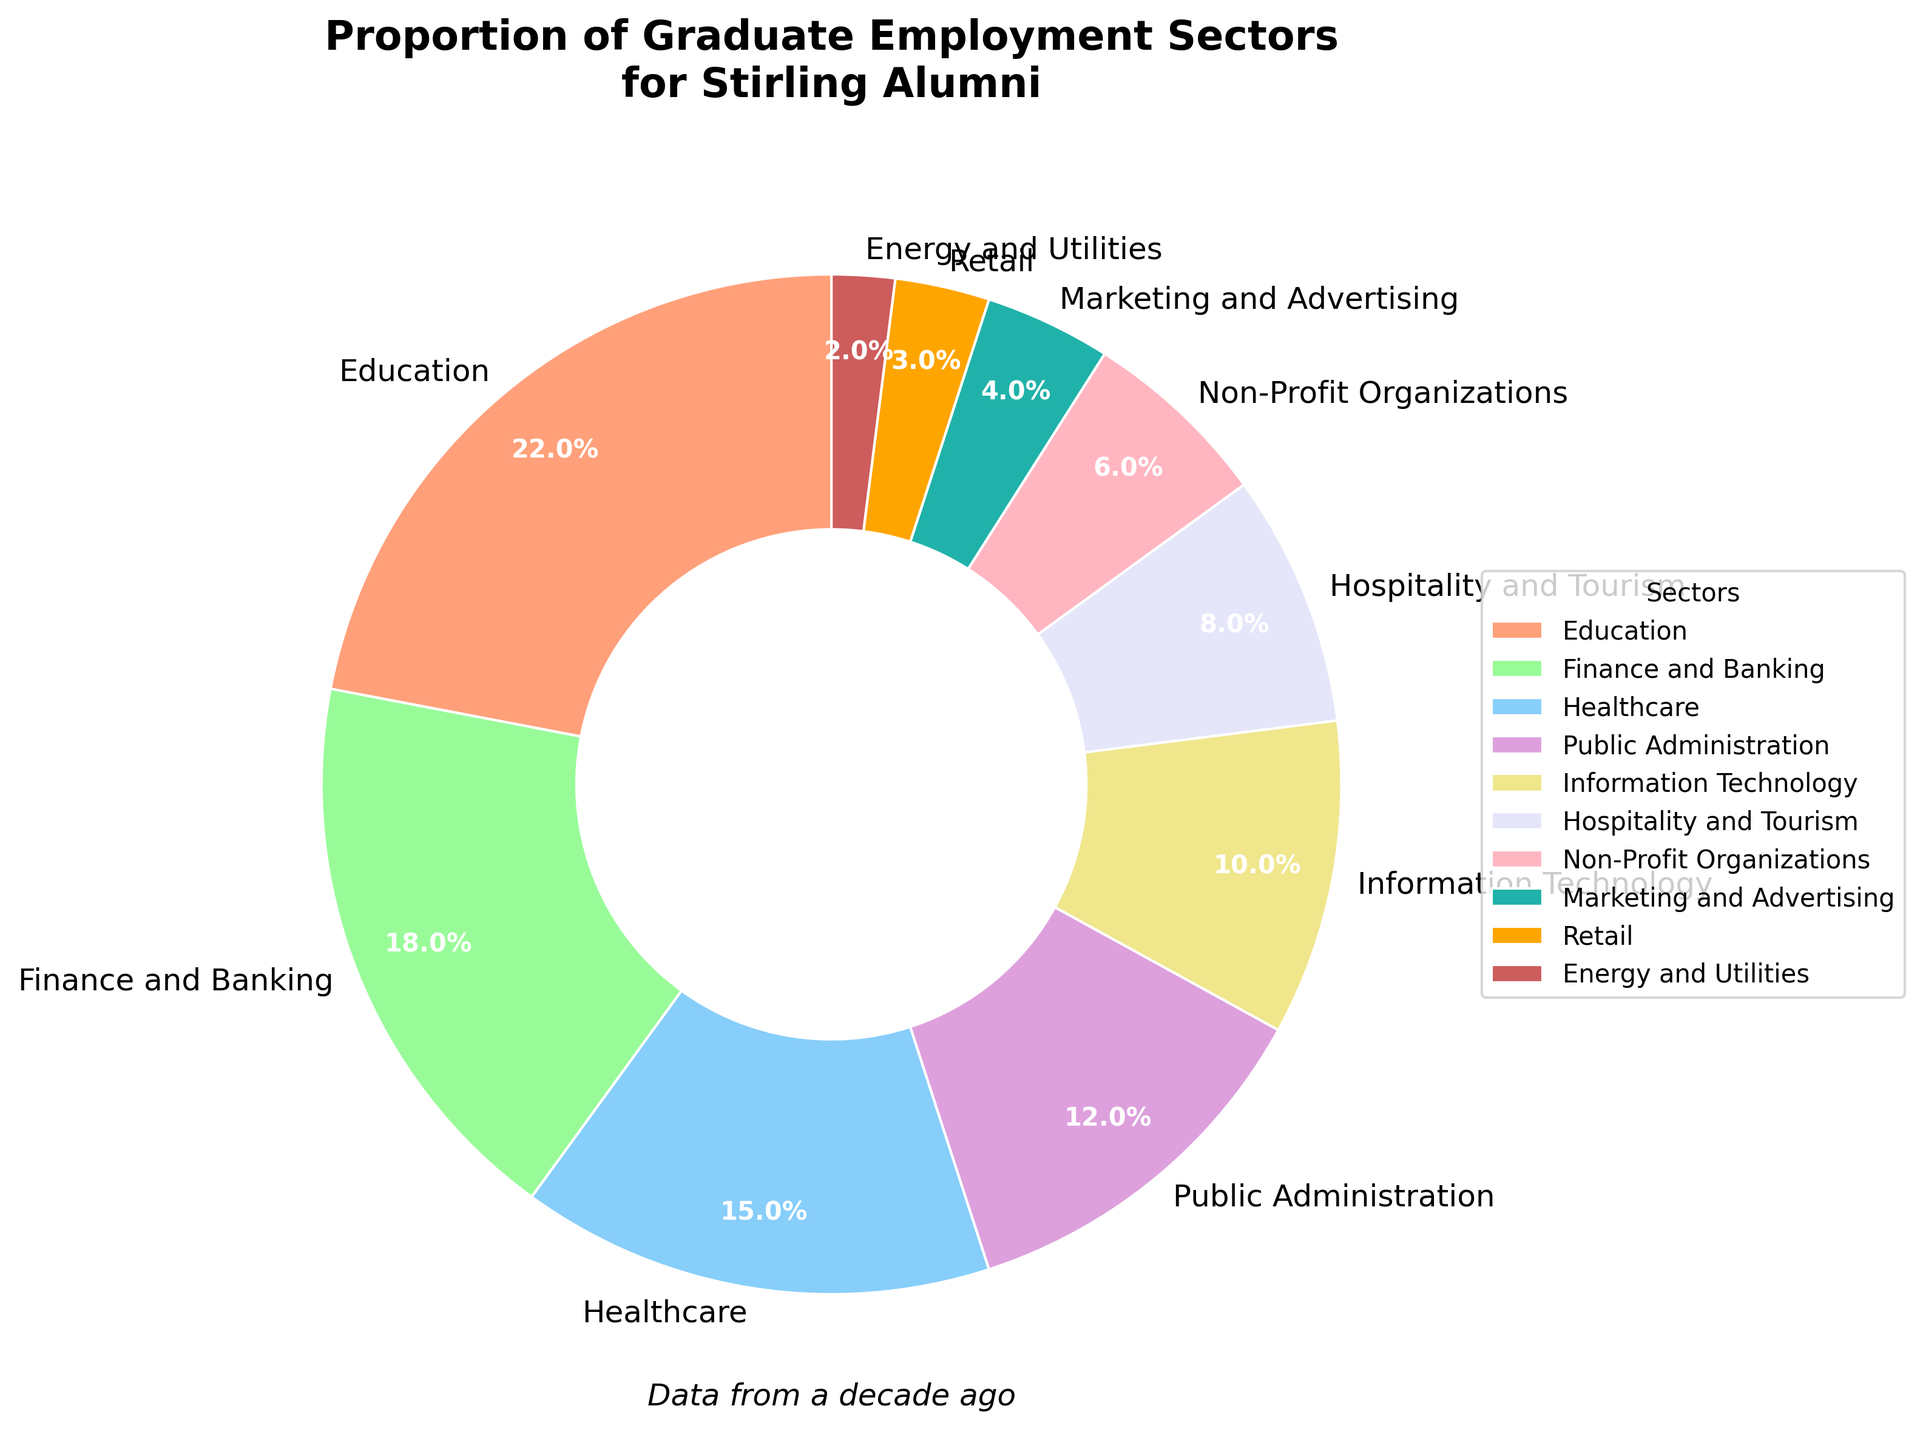What's the largest employment sector for Stirling alumni? To find the largest sector, look at the sector with the highest percentage value in the pie chart. Here, Education has the highest percentage at 22%.
Answer: Education What's the smallest employment sector for Stirling alumni? To determine the smallest sector, locate the sector with the lowest percentage value. The Energy and Utilities sector has the smallest percentage at 2%.
Answer: Energy and Utilities How many sectors have a proportion of 10% or higher? Count the sectors in the pie chart that have percentages equal to or above 10%. The sectors are Education (22%), Finance and Banking (18%), Healthcare (15%), Public Administration (12%), and Information Technology (10%). There are 5 such sectors.
Answer: 5 What's the combined percentage for Finance and Banking, and Healthcare sectors? Add the percentages of the Finance and Banking (18%) and Healthcare (15%) sectors: 18% + 15% = 33%.
Answer: 33% How does the proportion of Healthcare compare to that of Non-Profit Organizations? Compare the percentages of Healthcare (15%) and Non-Profit Organizations (6%). Healthcare is greater than Non-Profit Organizations.
Answer: Healthcare is greater Which sector has twice the percentage of Marketing and Advertising? First, find the percentage of Marketing and Advertising (4%), then identify the sector that has twice this percentage: 4% * 2 = 8%. Hospitality and Tourism has 8%.
Answer: Hospitality and Tourism What's the difference in percentage points between Public Administration and Retail? Subtract Retail's percentage (3%) from Public Administration's percentage (12%): 12% - 3% = 9%.
Answer: 9% What color represents the Finance and Banking sector? Identify the sector labeled as Finance and Banking in the pie chart and note its color. The color used for Finance and Banking is a shade of green.
Answer: Green Which sectors combined make up exactly half of the total proportion? Find sectors whose combined percentages add up to 50%. Checking the values: Education (22%) + Finance and Banking (18%) + Healthcare (15%) is 55%, so we need a smaller combination. Education (22%) + Public Administration (12%) + Information Technology (10%) is 44%. Adding Hospitality and Tourism (8%) gives us 52%. The combination that adds up to exactly 50% is Education (22%) + Information Technology (10%) + Hospitality and Tourism (8%) + Non-Profit Organizations (6%) + Marketing and Advertising (4%).
Answer: Education, Information Technology, Hospitality and Tourism, Non-Profit Organizations, Marketing and Advertising 